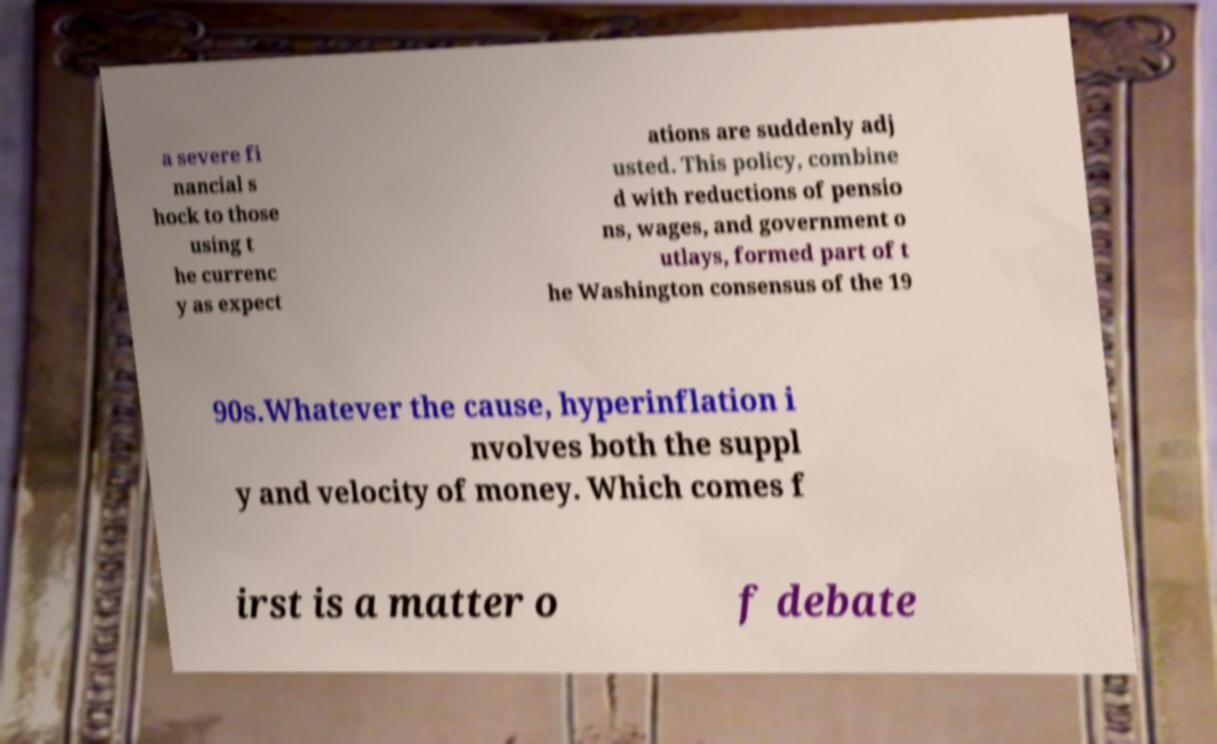What messages or text are displayed in this image? I need them in a readable, typed format. a severe fi nancial s hock to those using t he currenc y as expect ations are suddenly adj usted. This policy, combine d with reductions of pensio ns, wages, and government o utlays, formed part of t he Washington consensus of the 19 90s.Whatever the cause, hyperinflation i nvolves both the suppl y and velocity of money. Which comes f irst is a matter o f debate 